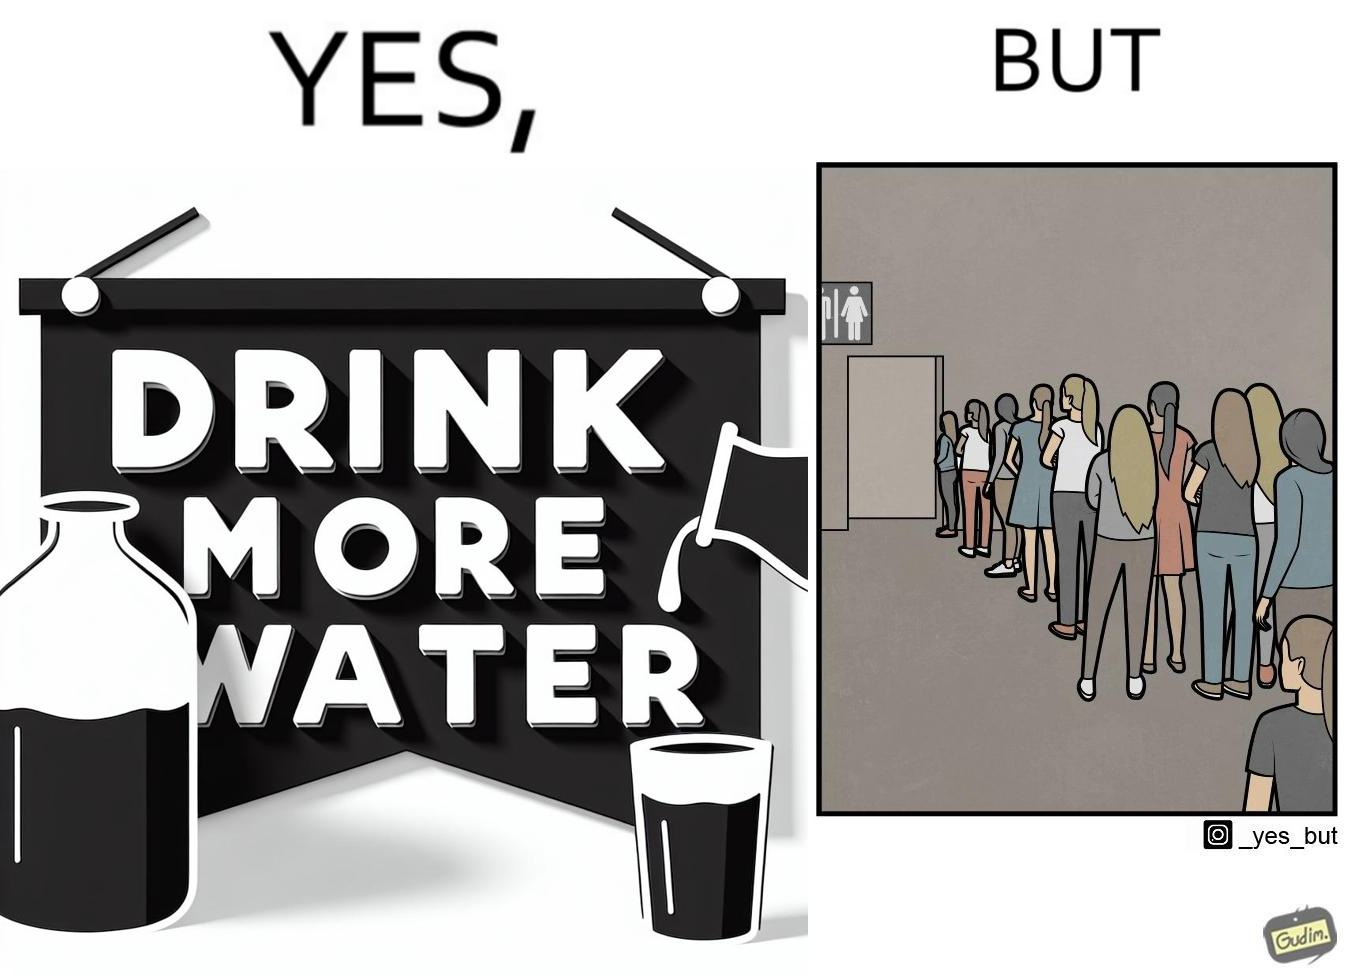Describe what you see in this image. The image is ironical, as the message "Drink more water" is meant to improve health, but in turn, it would lead to longer queues in front of public toilets, leading to people holding urine for longer periods, in turn leading to deterioration in health. 